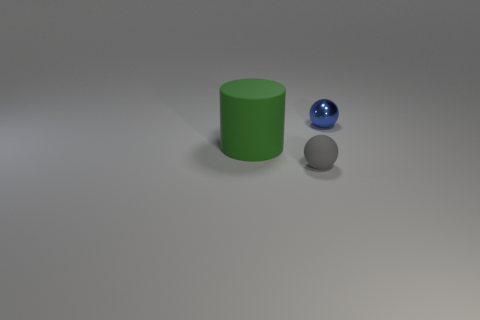The green cylinder is what size? The green cylinder appears to be medium-sized relative to the frame of the image, though without additional context or objects of known size for comparison, it's challenging to provide an accurate measurement. 